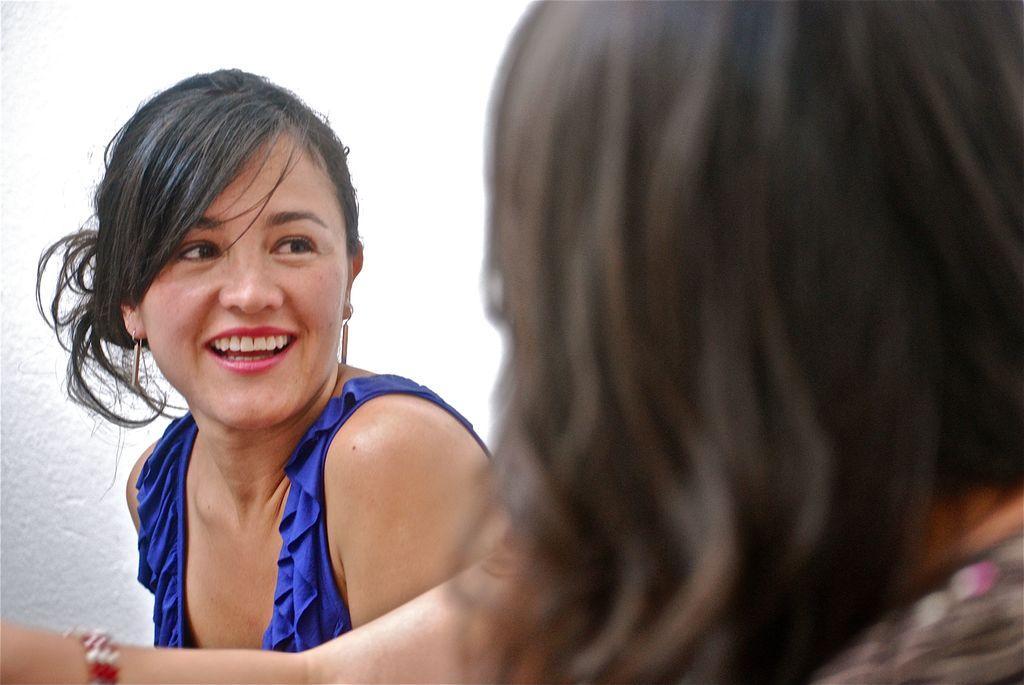In one or two sentences, can you explain what this image depicts? In the image there are two women facing each other and smiling, the woman on left side is wearing blue dress, behind them there is white wall. 